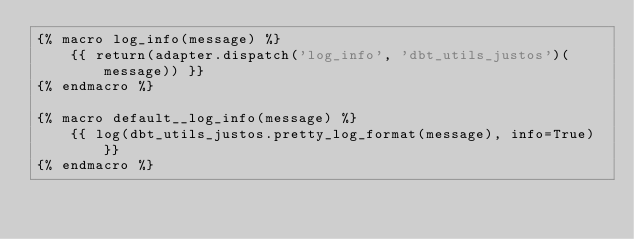<code> <loc_0><loc_0><loc_500><loc_500><_SQL_>{% macro log_info(message) %}
    {{ return(adapter.dispatch('log_info', 'dbt_utils_justos')(message)) }}
{% endmacro %}

{% macro default__log_info(message) %}
    {{ log(dbt_utils_justos.pretty_log_format(message), info=True) }}
{% endmacro %}
</code> 